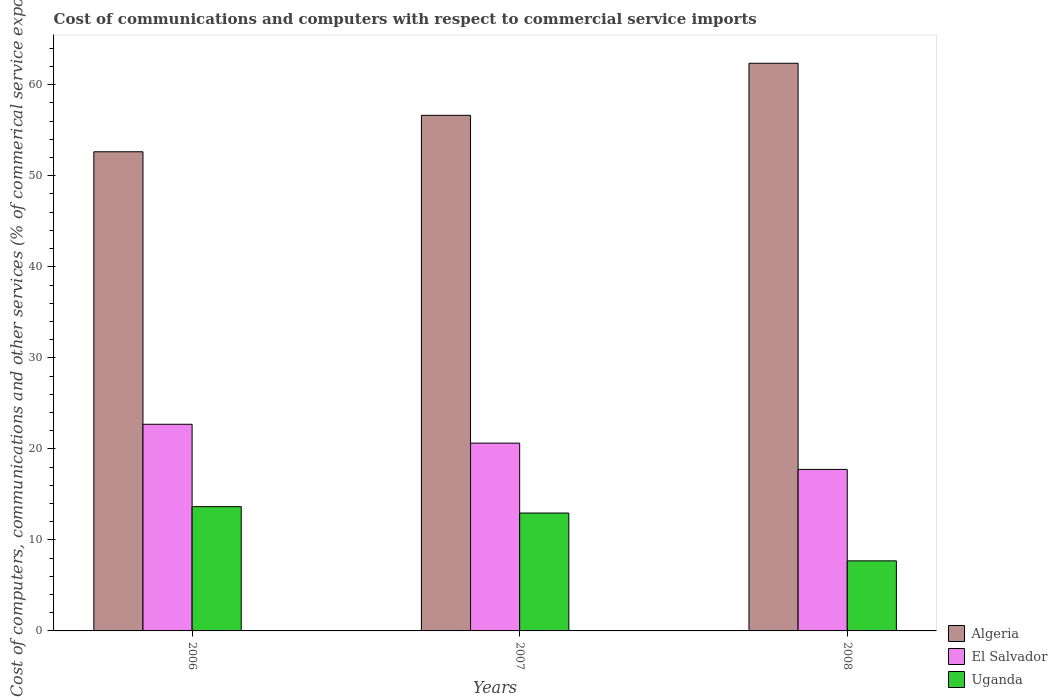How many different coloured bars are there?
Your answer should be compact. 3. Are the number of bars on each tick of the X-axis equal?
Ensure brevity in your answer.  Yes. How many bars are there on the 1st tick from the left?
Provide a succinct answer. 3. What is the cost of communications and computers in Uganda in 2007?
Offer a terse response. 12.95. Across all years, what is the maximum cost of communications and computers in Uganda?
Offer a terse response. 13.65. Across all years, what is the minimum cost of communications and computers in Uganda?
Provide a short and direct response. 7.7. In which year was the cost of communications and computers in Uganda minimum?
Ensure brevity in your answer.  2008. What is the total cost of communications and computers in Algeria in the graph?
Your response must be concise. 171.63. What is the difference between the cost of communications and computers in El Salvador in 2007 and that in 2008?
Offer a terse response. 2.89. What is the difference between the cost of communications and computers in Uganda in 2007 and the cost of communications and computers in Algeria in 2008?
Your response must be concise. -49.41. What is the average cost of communications and computers in Uganda per year?
Keep it short and to the point. 11.43. In the year 2006, what is the difference between the cost of communications and computers in Algeria and cost of communications and computers in Uganda?
Keep it short and to the point. 38.98. In how many years, is the cost of communications and computers in El Salvador greater than 14 %?
Keep it short and to the point. 3. What is the ratio of the cost of communications and computers in Uganda in 2006 to that in 2008?
Provide a succinct answer. 1.77. What is the difference between the highest and the second highest cost of communications and computers in Uganda?
Make the answer very short. 0.7. What is the difference between the highest and the lowest cost of communications and computers in Uganda?
Offer a terse response. 5.95. In how many years, is the cost of communications and computers in Algeria greater than the average cost of communications and computers in Algeria taken over all years?
Provide a succinct answer. 1. What does the 3rd bar from the left in 2008 represents?
Ensure brevity in your answer.  Uganda. What does the 1st bar from the right in 2007 represents?
Offer a terse response. Uganda. How many bars are there?
Provide a succinct answer. 9. Are all the bars in the graph horizontal?
Your answer should be compact. No. Where does the legend appear in the graph?
Ensure brevity in your answer.  Bottom right. How are the legend labels stacked?
Give a very brief answer. Vertical. What is the title of the graph?
Offer a terse response. Cost of communications and computers with respect to commercial service imports. What is the label or title of the Y-axis?
Offer a very short reply. Cost of computers, communications and other services (% of commerical service exports). What is the Cost of computers, communications and other services (% of commerical service exports) of Algeria in 2006?
Your answer should be compact. 52.64. What is the Cost of computers, communications and other services (% of commerical service exports) of El Salvador in 2006?
Ensure brevity in your answer.  22.7. What is the Cost of computers, communications and other services (% of commerical service exports) of Uganda in 2006?
Provide a succinct answer. 13.65. What is the Cost of computers, communications and other services (% of commerical service exports) of Algeria in 2007?
Offer a very short reply. 56.64. What is the Cost of computers, communications and other services (% of commerical service exports) in El Salvador in 2007?
Give a very brief answer. 20.63. What is the Cost of computers, communications and other services (% of commerical service exports) in Uganda in 2007?
Offer a very short reply. 12.95. What is the Cost of computers, communications and other services (% of commerical service exports) in Algeria in 2008?
Ensure brevity in your answer.  62.36. What is the Cost of computers, communications and other services (% of commerical service exports) of El Salvador in 2008?
Offer a very short reply. 17.74. What is the Cost of computers, communications and other services (% of commerical service exports) of Uganda in 2008?
Your answer should be very brief. 7.7. Across all years, what is the maximum Cost of computers, communications and other services (% of commerical service exports) of Algeria?
Give a very brief answer. 62.36. Across all years, what is the maximum Cost of computers, communications and other services (% of commerical service exports) in El Salvador?
Offer a terse response. 22.7. Across all years, what is the maximum Cost of computers, communications and other services (% of commerical service exports) of Uganda?
Provide a succinct answer. 13.65. Across all years, what is the minimum Cost of computers, communications and other services (% of commerical service exports) in Algeria?
Ensure brevity in your answer.  52.64. Across all years, what is the minimum Cost of computers, communications and other services (% of commerical service exports) in El Salvador?
Your response must be concise. 17.74. Across all years, what is the minimum Cost of computers, communications and other services (% of commerical service exports) of Uganda?
Your answer should be very brief. 7.7. What is the total Cost of computers, communications and other services (% of commerical service exports) of Algeria in the graph?
Your response must be concise. 171.63. What is the total Cost of computers, communications and other services (% of commerical service exports) of El Salvador in the graph?
Give a very brief answer. 61.07. What is the total Cost of computers, communications and other services (% of commerical service exports) of Uganda in the graph?
Offer a terse response. 34.3. What is the difference between the Cost of computers, communications and other services (% of commerical service exports) in Algeria in 2006 and that in 2007?
Make the answer very short. -4. What is the difference between the Cost of computers, communications and other services (% of commerical service exports) in El Salvador in 2006 and that in 2007?
Keep it short and to the point. 2.07. What is the difference between the Cost of computers, communications and other services (% of commerical service exports) of Uganda in 2006 and that in 2007?
Your response must be concise. 0.7. What is the difference between the Cost of computers, communications and other services (% of commerical service exports) in Algeria in 2006 and that in 2008?
Provide a succinct answer. -9.72. What is the difference between the Cost of computers, communications and other services (% of commerical service exports) of El Salvador in 2006 and that in 2008?
Offer a terse response. 4.96. What is the difference between the Cost of computers, communications and other services (% of commerical service exports) in Uganda in 2006 and that in 2008?
Keep it short and to the point. 5.95. What is the difference between the Cost of computers, communications and other services (% of commerical service exports) of Algeria in 2007 and that in 2008?
Your response must be concise. -5.72. What is the difference between the Cost of computers, communications and other services (% of commerical service exports) in El Salvador in 2007 and that in 2008?
Provide a succinct answer. 2.88. What is the difference between the Cost of computers, communications and other services (% of commerical service exports) in Uganda in 2007 and that in 2008?
Your answer should be compact. 5.25. What is the difference between the Cost of computers, communications and other services (% of commerical service exports) of Algeria in 2006 and the Cost of computers, communications and other services (% of commerical service exports) of El Salvador in 2007?
Keep it short and to the point. 32.01. What is the difference between the Cost of computers, communications and other services (% of commerical service exports) of Algeria in 2006 and the Cost of computers, communications and other services (% of commerical service exports) of Uganda in 2007?
Offer a terse response. 39.69. What is the difference between the Cost of computers, communications and other services (% of commerical service exports) in El Salvador in 2006 and the Cost of computers, communications and other services (% of commerical service exports) in Uganda in 2007?
Offer a very short reply. 9.75. What is the difference between the Cost of computers, communications and other services (% of commerical service exports) of Algeria in 2006 and the Cost of computers, communications and other services (% of commerical service exports) of El Salvador in 2008?
Make the answer very short. 34.89. What is the difference between the Cost of computers, communications and other services (% of commerical service exports) in Algeria in 2006 and the Cost of computers, communications and other services (% of commerical service exports) in Uganda in 2008?
Keep it short and to the point. 44.94. What is the difference between the Cost of computers, communications and other services (% of commerical service exports) in El Salvador in 2006 and the Cost of computers, communications and other services (% of commerical service exports) in Uganda in 2008?
Give a very brief answer. 15. What is the difference between the Cost of computers, communications and other services (% of commerical service exports) in Algeria in 2007 and the Cost of computers, communications and other services (% of commerical service exports) in El Salvador in 2008?
Ensure brevity in your answer.  38.9. What is the difference between the Cost of computers, communications and other services (% of commerical service exports) in Algeria in 2007 and the Cost of computers, communications and other services (% of commerical service exports) in Uganda in 2008?
Ensure brevity in your answer.  48.94. What is the difference between the Cost of computers, communications and other services (% of commerical service exports) of El Salvador in 2007 and the Cost of computers, communications and other services (% of commerical service exports) of Uganda in 2008?
Ensure brevity in your answer.  12.93. What is the average Cost of computers, communications and other services (% of commerical service exports) of Algeria per year?
Provide a short and direct response. 57.21. What is the average Cost of computers, communications and other services (% of commerical service exports) of El Salvador per year?
Keep it short and to the point. 20.36. What is the average Cost of computers, communications and other services (% of commerical service exports) in Uganda per year?
Make the answer very short. 11.43. In the year 2006, what is the difference between the Cost of computers, communications and other services (% of commerical service exports) of Algeria and Cost of computers, communications and other services (% of commerical service exports) of El Salvador?
Ensure brevity in your answer.  29.94. In the year 2006, what is the difference between the Cost of computers, communications and other services (% of commerical service exports) of Algeria and Cost of computers, communications and other services (% of commerical service exports) of Uganda?
Your answer should be compact. 38.98. In the year 2006, what is the difference between the Cost of computers, communications and other services (% of commerical service exports) of El Salvador and Cost of computers, communications and other services (% of commerical service exports) of Uganda?
Your response must be concise. 9.05. In the year 2007, what is the difference between the Cost of computers, communications and other services (% of commerical service exports) of Algeria and Cost of computers, communications and other services (% of commerical service exports) of El Salvador?
Provide a short and direct response. 36.01. In the year 2007, what is the difference between the Cost of computers, communications and other services (% of commerical service exports) in Algeria and Cost of computers, communications and other services (% of commerical service exports) in Uganda?
Offer a very short reply. 43.69. In the year 2007, what is the difference between the Cost of computers, communications and other services (% of commerical service exports) in El Salvador and Cost of computers, communications and other services (% of commerical service exports) in Uganda?
Keep it short and to the point. 7.68. In the year 2008, what is the difference between the Cost of computers, communications and other services (% of commerical service exports) of Algeria and Cost of computers, communications and other services (% of commerical service exports) of El Salvador?
Keep it short and to the point. 44.62. In the year 2008, what is the difference between the Cost of computers, communications and other services (% of commerical service exports) in Algeria and Cost of computers, communications and other services (% of commerical service exports) in Uganda?
Keep it short and to the point. 54.66. In the year 2008, what is the difference between the Cost of computers, communications and other services (% of commerical service exports) of El Salvador and Cost of computers, communications and other services (% of commerical service exports) of Uganda?
Offer a terse response. 10.04. What is the ratio of the Cost of computers, communications and other services (% of commerical service exports) in Algeria in 2006 to that in 2007?
Keep it short and to the point. 0.93. What is the ratio of the Cost of computers, communications and other services (% of commerical service exports) in El Salvador in 2006 to that in 2007?
Your answer should be very brief. 1.1. What is the ratio of the Cost of computers, communications and other services (% of commerical service exports) in Uganda in 2006 to that in 2007?
Your response must be concise. 1.05. What is the ratio of the Cost of computers, communications and other services (% of commerical service exports) in Algeria in 2006 to that in 2008?
Give a very brief answer. 0.84. What is the ratio of the Cost of computers, communications and other services (% of commerical service exports) in El Salvador in 2006 to that in 2008?
Your answer should be compact. 1.28. What is the ratio of the Cost of computers, communications and other services (% of commerical service exports) of Uganda in 2006 to that in 2008?
Your answer should be very brief. 1.77. What is the ratio of the Cost of computers, communications and other services (% of commerical service exports) in Algeria in 2007 to that in 2008?
Keep it short and to the point. 0.91. What is the ratio of the Cost of computers, communications and other services (% of commerical service exports) of El Salvador in 2007 to that in 2008?
Offer a terse response. 1.16. What is the ratio of the Cost of computers, communications and other services (% of commerical service exports) in Uganda in 2007 to that in 2008?
Make the answer very short. 1.68. What is the difference between the highest and the second highest Cost of computers, communications and other services (% of commerical service exports) of Algeria?
Keep it short and to the point. 5.72. What is the difference between the highest and the second highest Cost of computers, communications and other services (% of commerical service exports) in El Salvador?
Provide a short and direct response. 2.07. What is the difference between the highest and the second highest Cost of computers, communications and other services (% of commerical service exports) in Uganda?
Your answer should be very brief. 0.7. What is the difference between the highest and the lowest Cost of computers, communications and other services (% of commerical service exports) of Algeria?
Your answer should be very brief. 9.72. What is the difference between the highest and the lowest Cost of computers, communications and other services (% of commerical service exports) of El Salvador?
Provide a short and direct response. 4.96. What is the difference between the highest and the lowest Cost of computers, communications and other services (% of commerical service exports) of Uganda?
Keep it short and to the point. 5.95. 